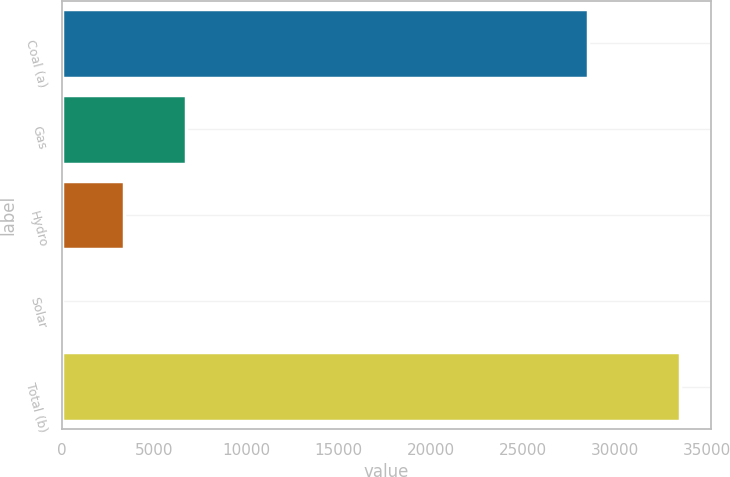Convert chart. <chart><loc_0><loc_0><loc_500><loc_500><bar_chart><fcel>Coal (a)<fcel>Gas<fcel>Hydro<fcel>Solar<fcel>Total (b)<nl><fcel>28519<fcel>6714.2<fcel>3366.1<fcel>18<fcel>33499<nl></chart> 